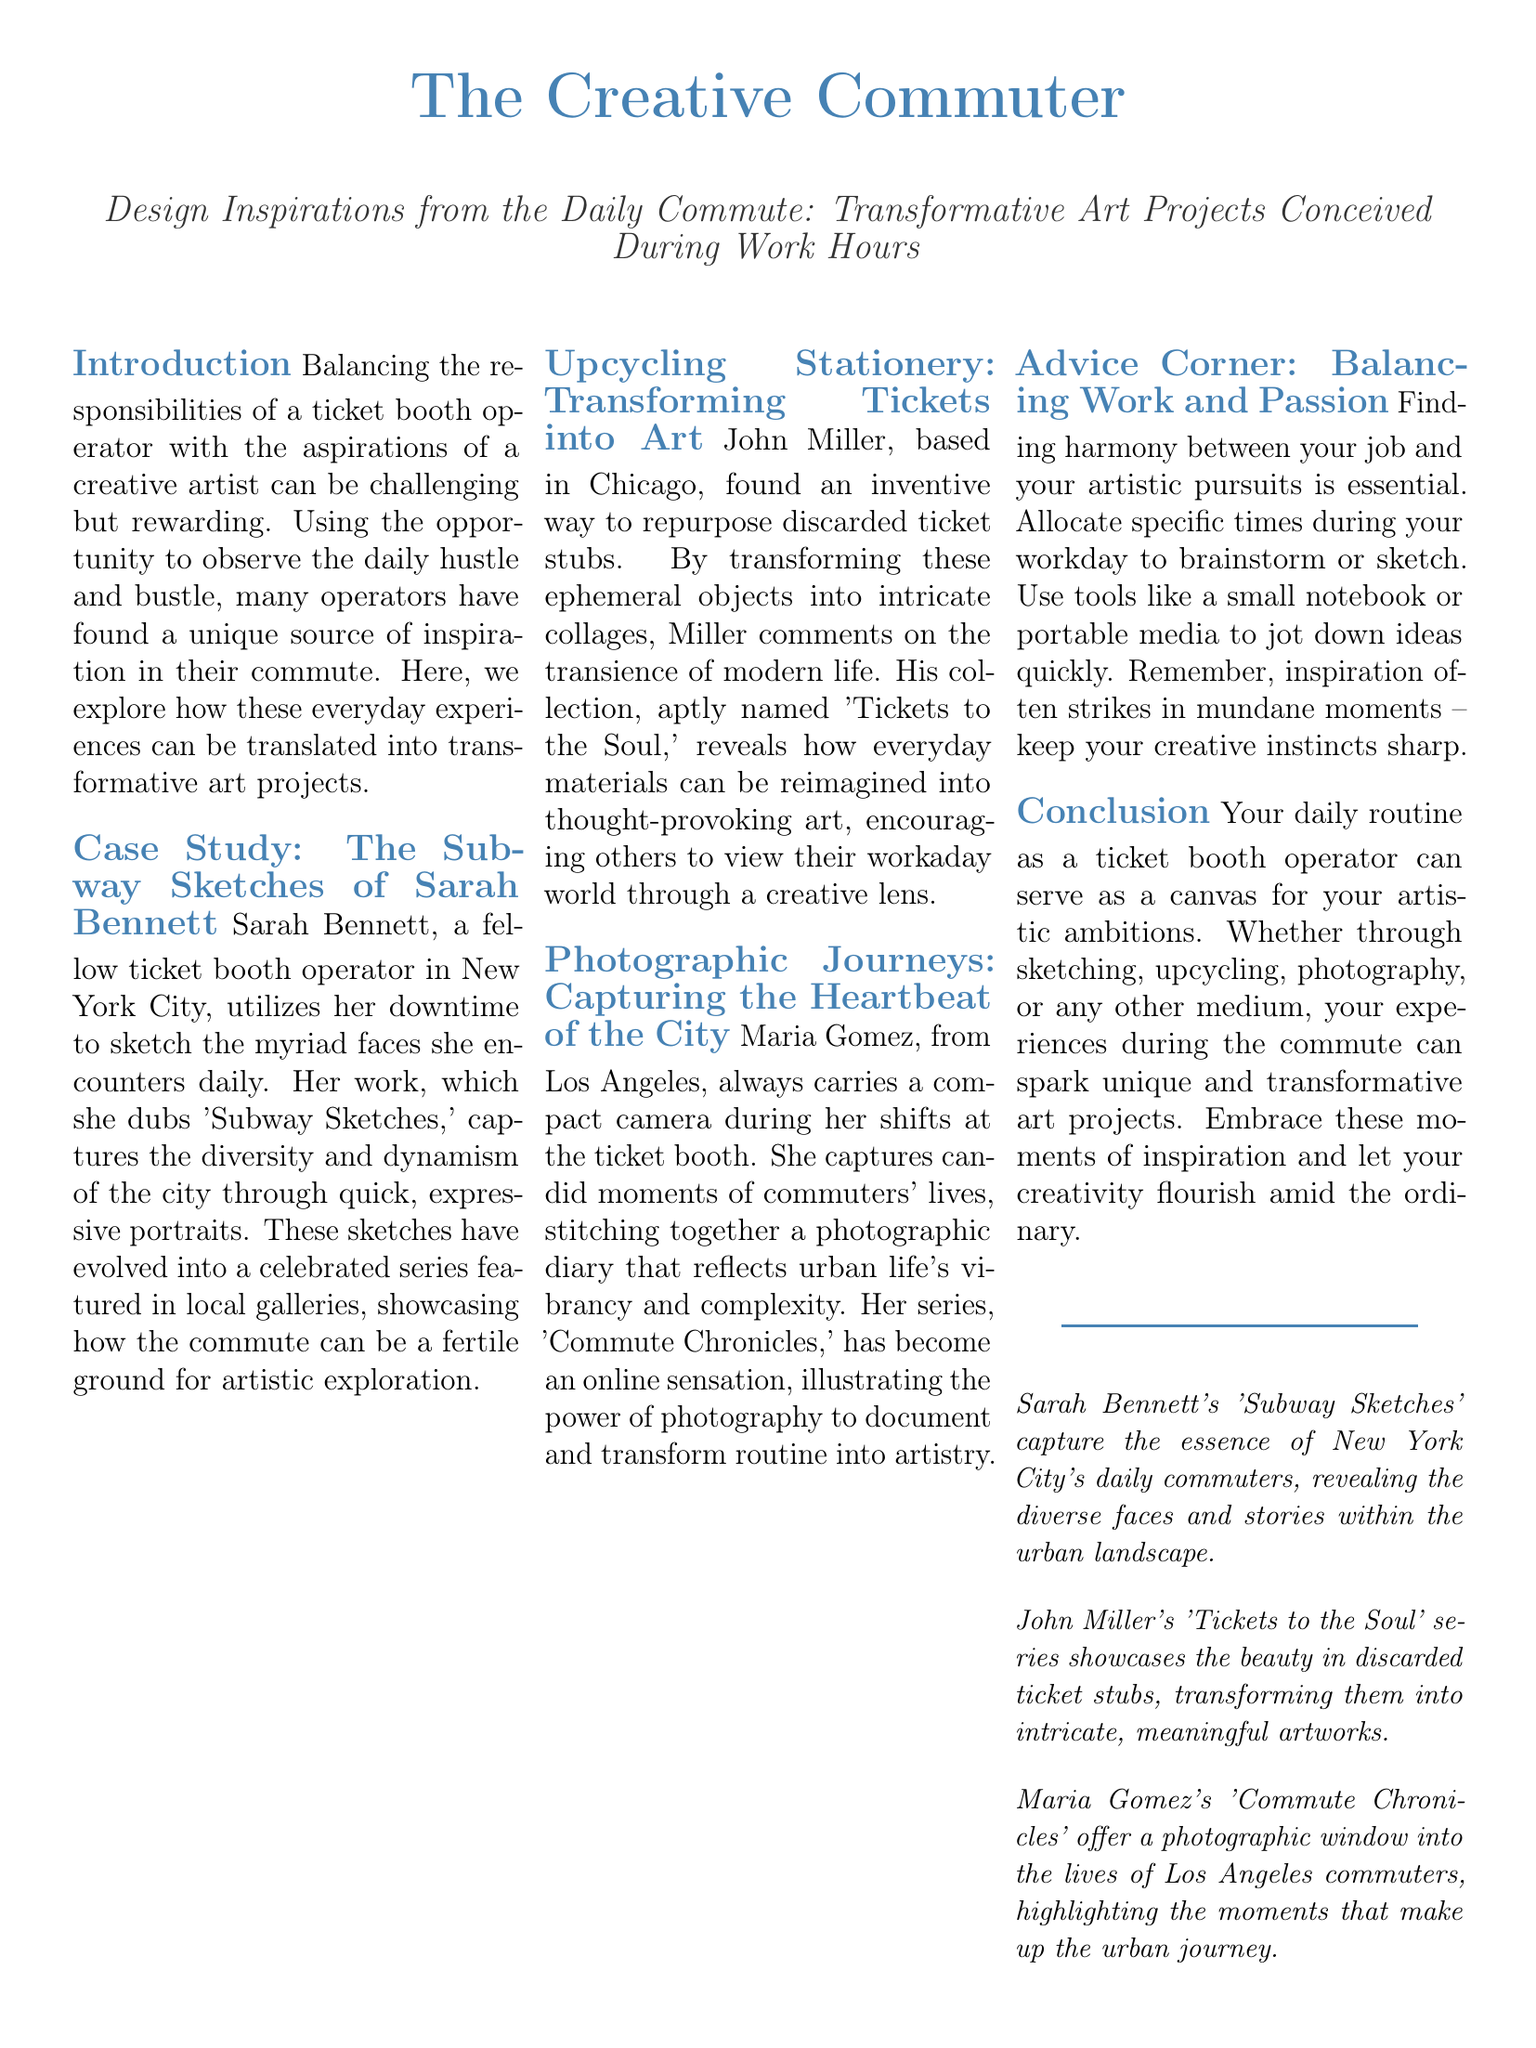What is the title of the document? The title of the document is clearly stated at the top.
Answer: The Creative Commuter Who are the featured artists in the document? The document lists three case studies of artists inspired by their commutes.
Answer: Sarah Bennett, John Miller, Maria Gomez What is Sarah Bennett's art series called? The document mentions the name of Sarah Bennett's series specifically.
Answer: Subway Sketches What materials did John Miller use for his art? The document specifically identifies the materials he repurposed for his project.
Answer: Discarded ticket stubs What is the advice given for balancing work and passion? The document presents specific strategies for maintaining both job duties and artistic pursuits.
Answer: Allocate specific times during your workday How many columns are there in the layout? The layout discusses a structured format, which can be determined from the description.
Answer: Three What city does Maria Gomez's work originate from? The document provides the location associated with her art project.
Answer: Los Angeles What is the name of John Miller's art collection? The document states the name of Miller's collection directly.
Answer: Tickets to the Soul 